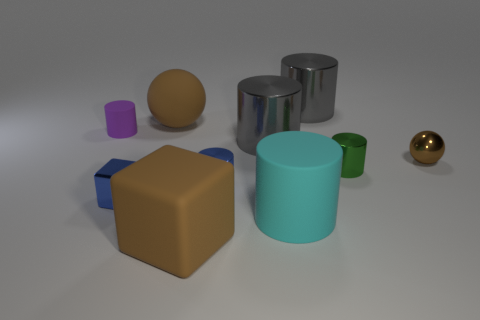Subtract all blue cylinders. How many cylinders are left? 5 Subtract all large cyan cylinders. How many cylinders are left? 5 Subtract all brown cylinders. Subtract all purple blocks. How many cylinders are left? 6 Subtract all blocks. How many objects are left? 8 Subtract 0 blue spheres. How many objects are left? 10 Subtract all tiny matte cylinders. Subtract all big spheres. How many objects are left? 8 Add 7 tiny green things. How many tiny green things are left? 8 Add 1 tiny purple matte cylinders. How many tiny purple matte cylinders exist? 2 